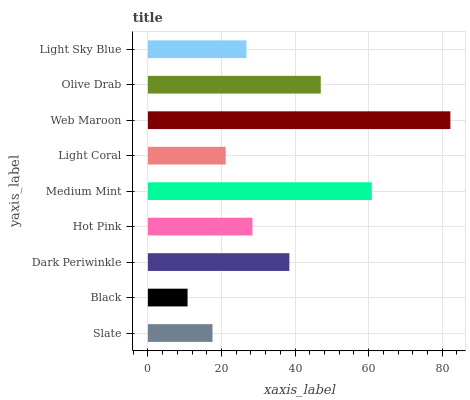Is Black the minimum?
Answer yes or no. Yes. Is Web Maroon the maximum?
Answer yes or no. Yes. Is Dark Periwinkle the minimum?
Answer yes or no. No. Is Dark Periwinkle the maximum?
Answer yes or no. No. Is Dark Periwinkle greater than Black?
Answer yes or no. Yes. Is Black less than Dark Periwinkle?
Answer yes or no. Yes. Is Black greater than Dark Periwinkle?
Answer yes or no. No. Is Dark Periwinkle less than Black?
Answer yes or no. No. Is Hot Pink the high median?
Answer yes or no. Yes. Is Hot Pink the low median?
Answer yes or no. Yes. Is Light Sky Blue the high median?
Answer yes or no. No. Is Slate the low median?
Answer yes or no. No. 